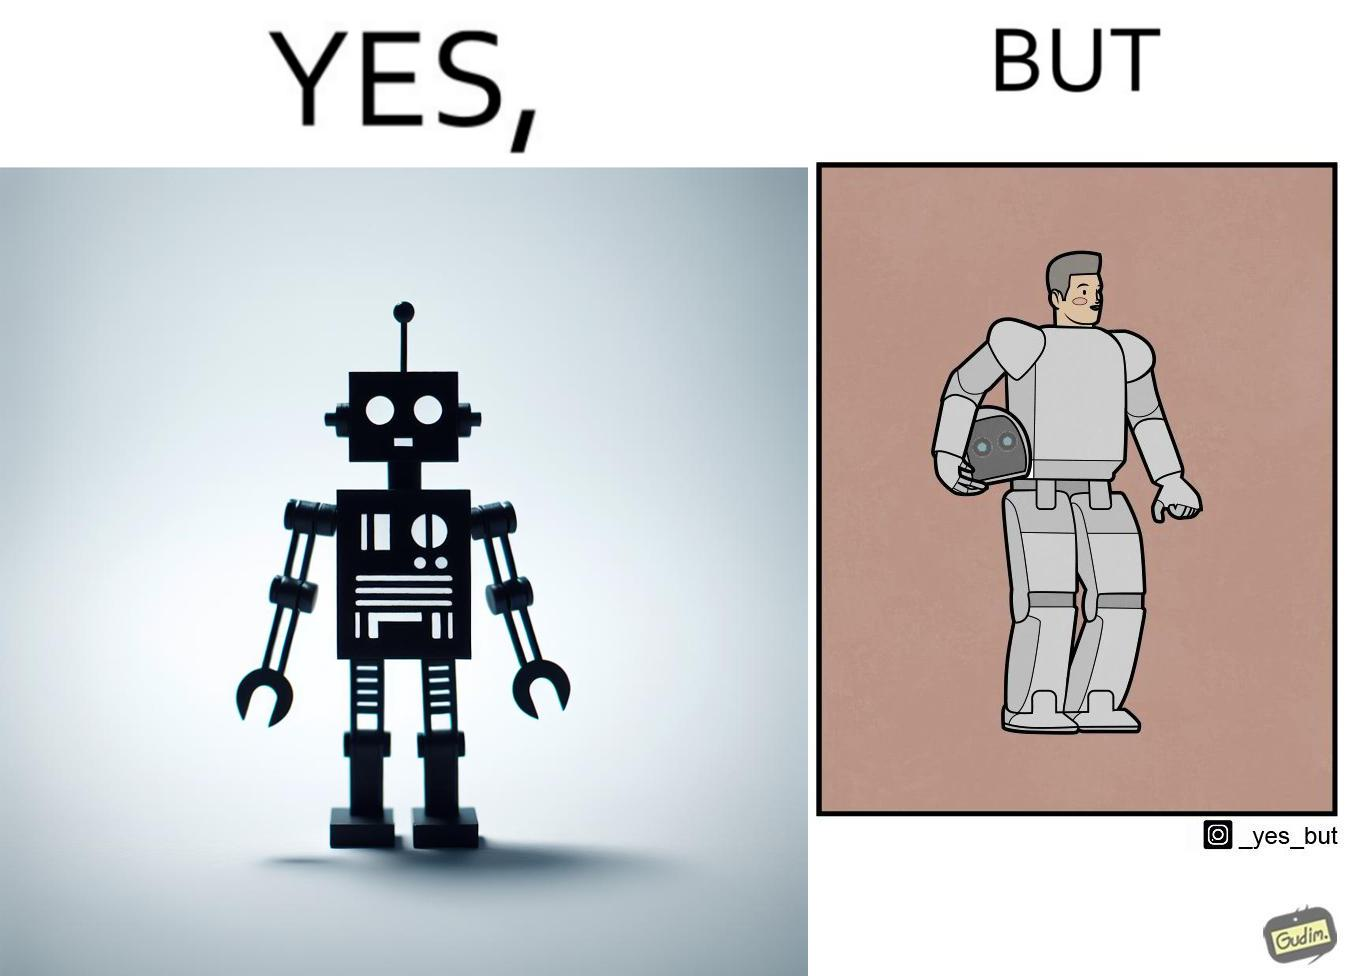Is this a satirical image? Yes, this image is satirical. 